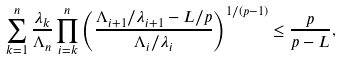Convert formula to latex. <formula><loc_0><loc_0><loc_500><loc_500>\sum ^ { n } _ { k = 1 } \frac { \lambda _ { k } } { \Lambda _ { n } } \prod ^ { n } _ { i = k } \left ( \frac { \Lambda _ { i + 1 } / \lambda _ { i + 1 } - L / p } { \Lambda _ { i } / \lambda _ { i } } \right ) ^ { 1 / ( p - 1 ) } \leq \frac { p } { p - L } ,</formula> 